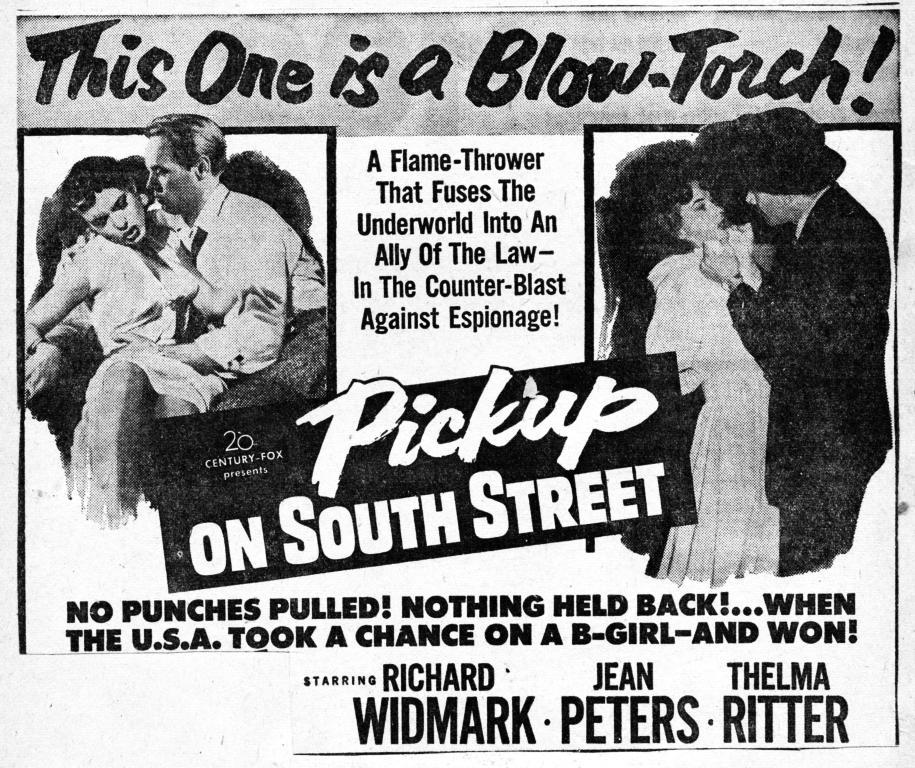What is the main subject of the poster in the image? The poster contains pictures of a couple. What else can be seen on the poster besides the images of the couple? There is text written on the poster. What type of sink is visible in the image? There is no sink present in the image. What experience can be gained from looking at the poster? The poster itself does not provide an experience, but it may evoke emotions or thoughts based on the content. 